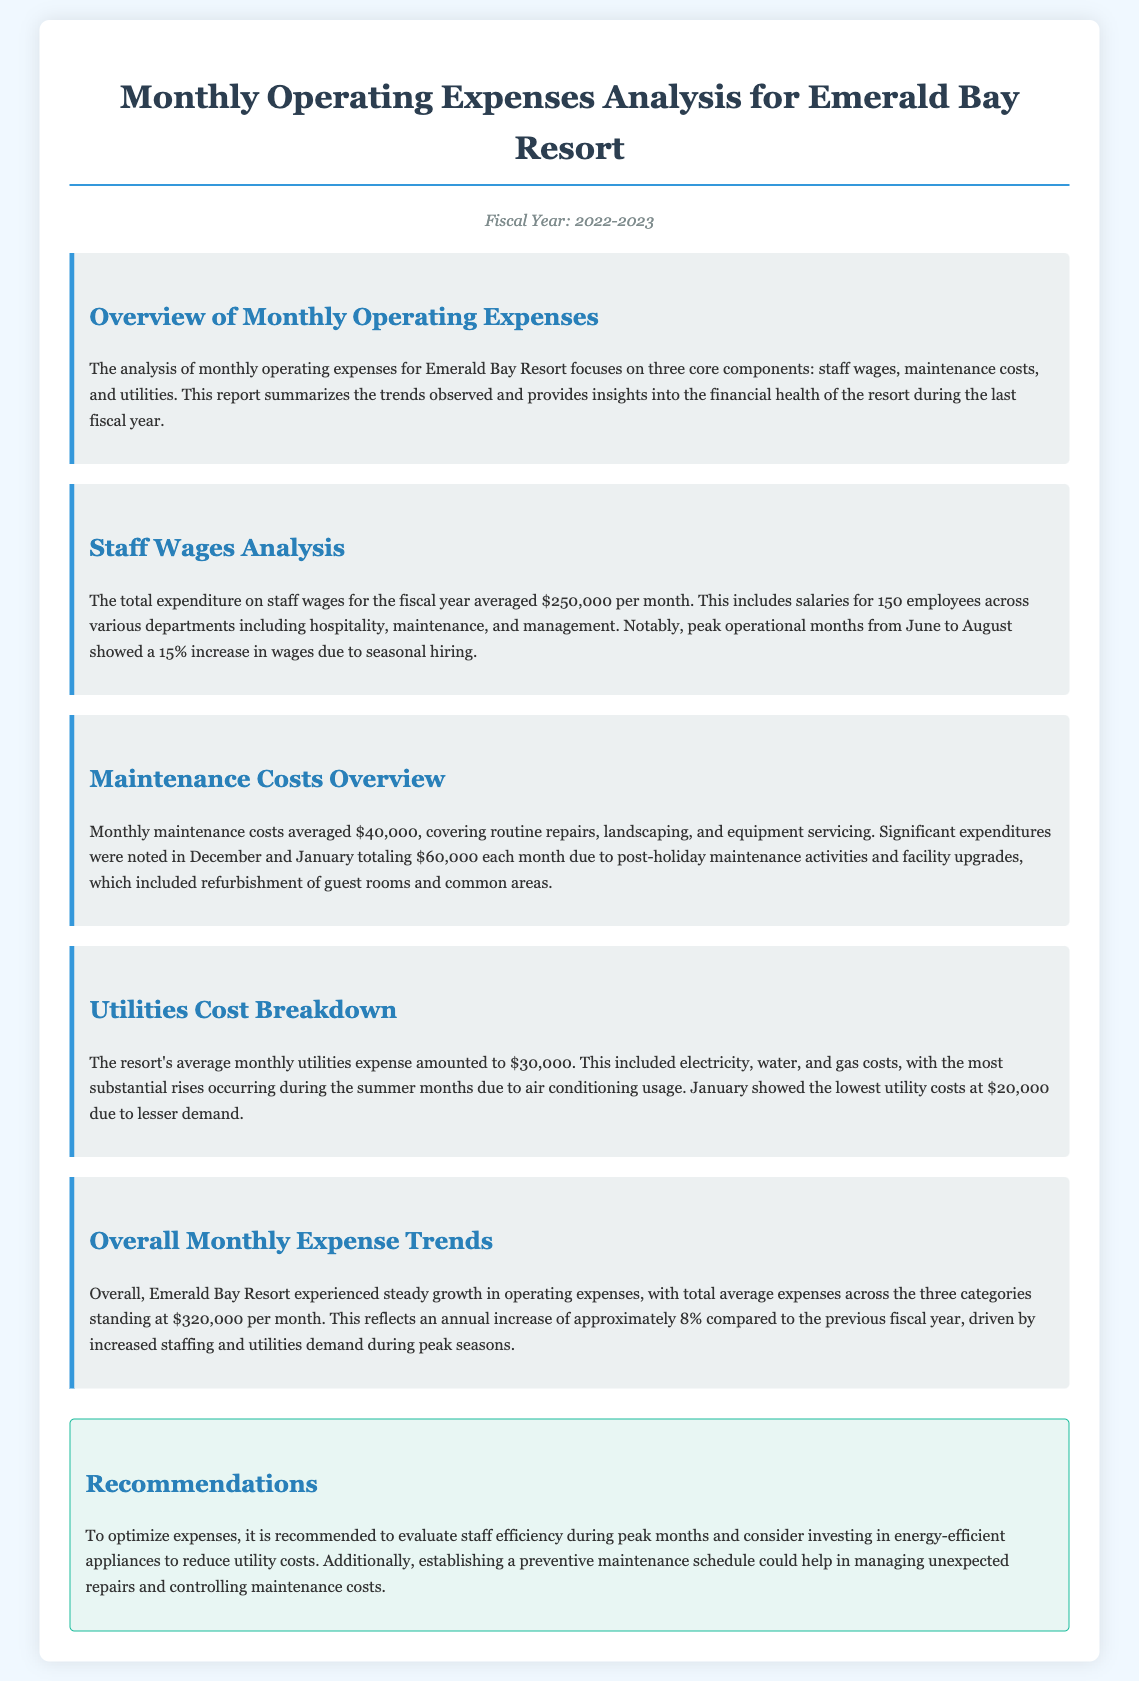what was the average monthly expenditure on staff wages? The document states that the average monthly expenditure on staff wages was $250,000.
Answer: $250,000 what were the peak operational months for staff wages? The report mentions that peak operational months for staff wages were from June to August.
Answer: June to August how much did maintenance costs average monthly? According to the document, monthly maintenance costs averaged $40,000.
Answer: $40,000 what were the maintenance costs in December and January? The report indicates that significant expenditures in December and January totaled $60,000 each month.
Answer: $60,000 what is the average monthly utilities expense? The document states that the average monthly utilities expense amounted to $30,000.
Answer: $30,000 in which month did the lowest utility costs occur? The report notes that January showed the lowest utility costs at $20,000.
Answer: January what was the total average expenses across the three categories? The total average expenses across the three categories stood at $320,000 per month.
Answer: $320,000 by what percentage did the annual expenses increase compared to the previous fiscal year? The annual increase in expenses is approximately 8% compared to the previous fiscal year.
Answer: 8% what recommendation is made to optimize expenses? The report recommends evaluating staff efficiency during peak months.
Answer: evaluating staff efficiency during peak months 